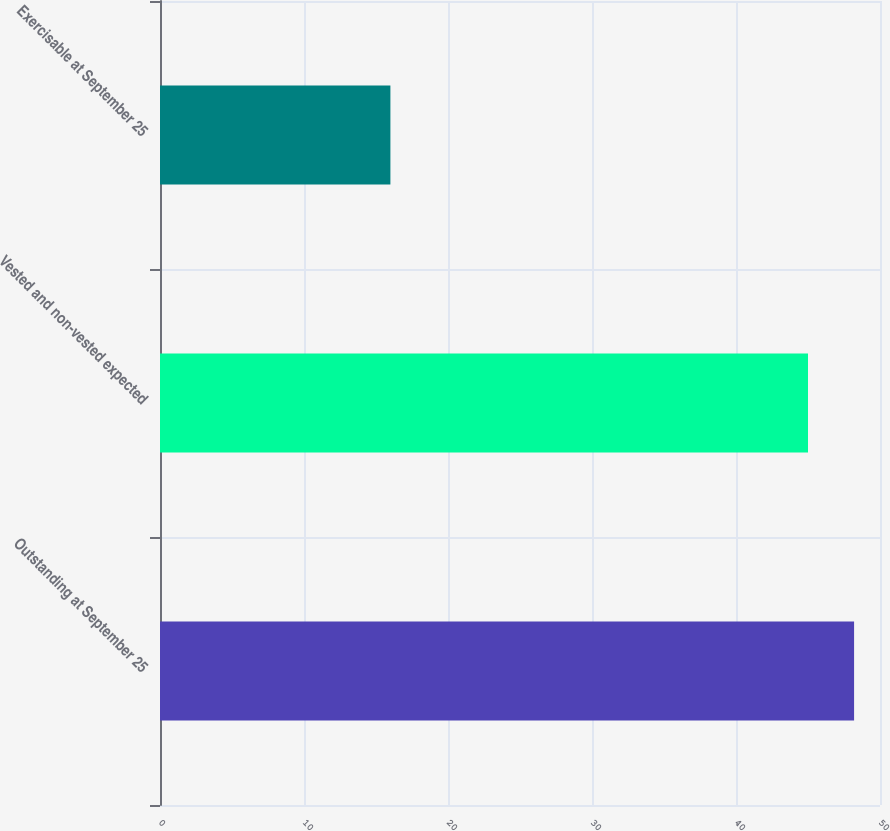<chart> <loc_0><loc_0><loc_500><loc_500><bar_chart><fcel>Outstanding at September 25<fcel>Vested and non-vested expected<fcel>Exercisable at September 25<nl><fcel>48.2<fcel>45<fcel>16<nl></chart> 